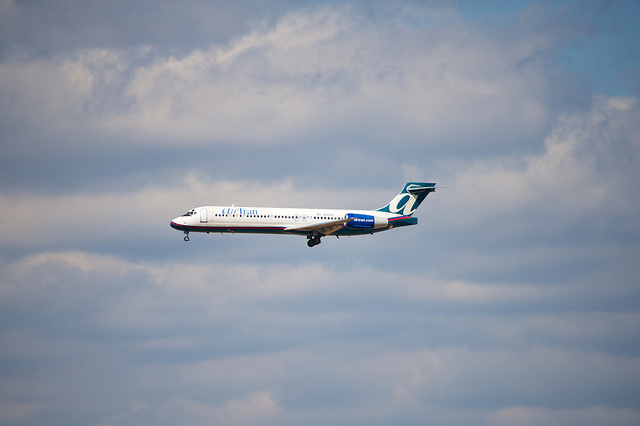<image>What does the side of the plane say? I don't know what the side of the plane says. It could say 'airtran', 'aloha' or 'airways'. What airliner is this? I don't know what airliner this is. It may be 'airtran', 'american', 'jetblue', 'air trans' or 'airbus'. What does the side of the plane say? I don't know what the side of the plane says. It could be 'airtran', 'aloha', 'air trans', or 'airways'. What airliner is this? It is ambiguous what airliner is shown in the image. It can be 'airtran', 'american', 'jetblue', 'air trans', 'american', 'airbus' or 'air'. 